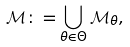<formula> <loc_0><loc_0><loc_500><loc_500>\mathcal { M } \colon = \bigcup _ { \theta \in \Theta } \mathcal { M } _ { \theta } ,</formula> 